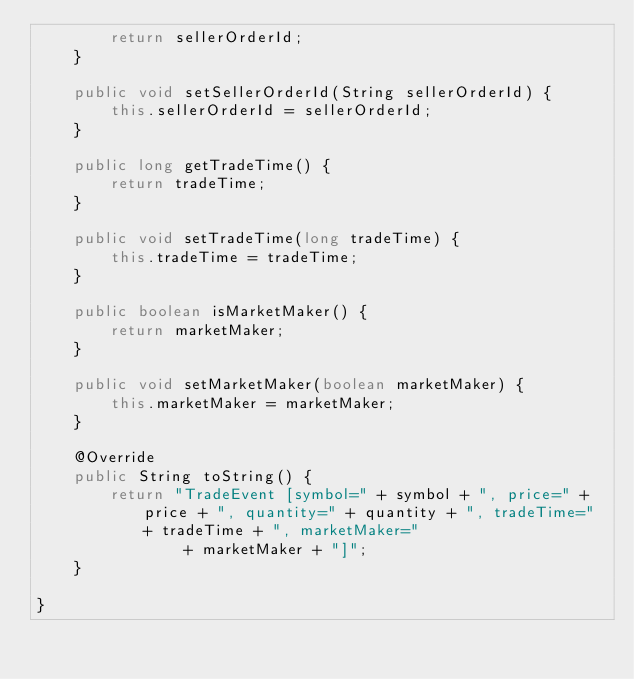Convert code to text. <code><loc_0><loc_0><loc_500><loc_500><_Java_>        return sellerOrderId;
    }

    public void setSellerOrderId(String sellerOrderId) {
        this.sellerOrderId = sellerOrderId;
    }

    public long getTradeTime() {
        return tradeTime;
    }

    public void setTradeTime(long tradeTime) {
        this.tradeTime = tradeTime;
    }

    public boolean isMarketMaker() {
        return marketMaker;
    }

    public void setMarketMaker(boolean marketMaker) {
        this.marketMaker = marketMaker;
    }

    @Override
    public String toString() {
        return "TradeEvent [symbol=" + symbol + ", price=" + price + ", quantity=" + quantity + ", tradeTime=" + tradeTime + ", marketMaker="
                + marketMaker + "]";
    }

}</code> 